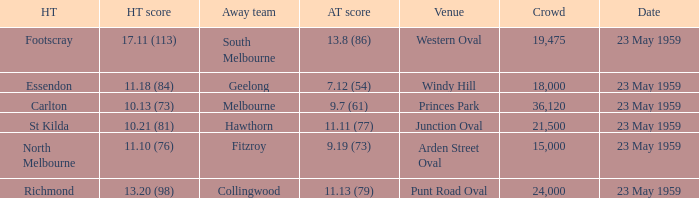What was the home team's score at the game that had a crowd larger than 24,000? 10.13 (73). 